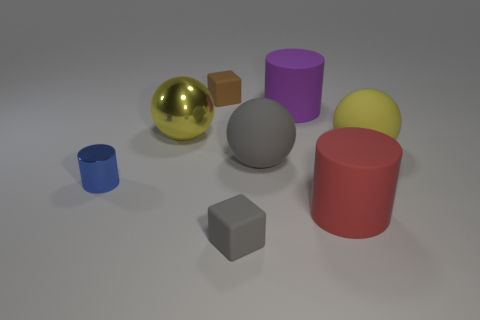Add 1 cylinders. How many objects exist? 9 Subtract all cylinders. How many objects are left? 5 Add 1 tiny shiny cylinders. How many tiny shiny cylinders are left? 2 Add 6 gray metal cylinders. How many gray metal cylinders exist? 6 Subtract 1 gray balls. How many objects are left? 7 Subtract all large red cylinders. Subtract all brown cubes. How many objects are left? 6 